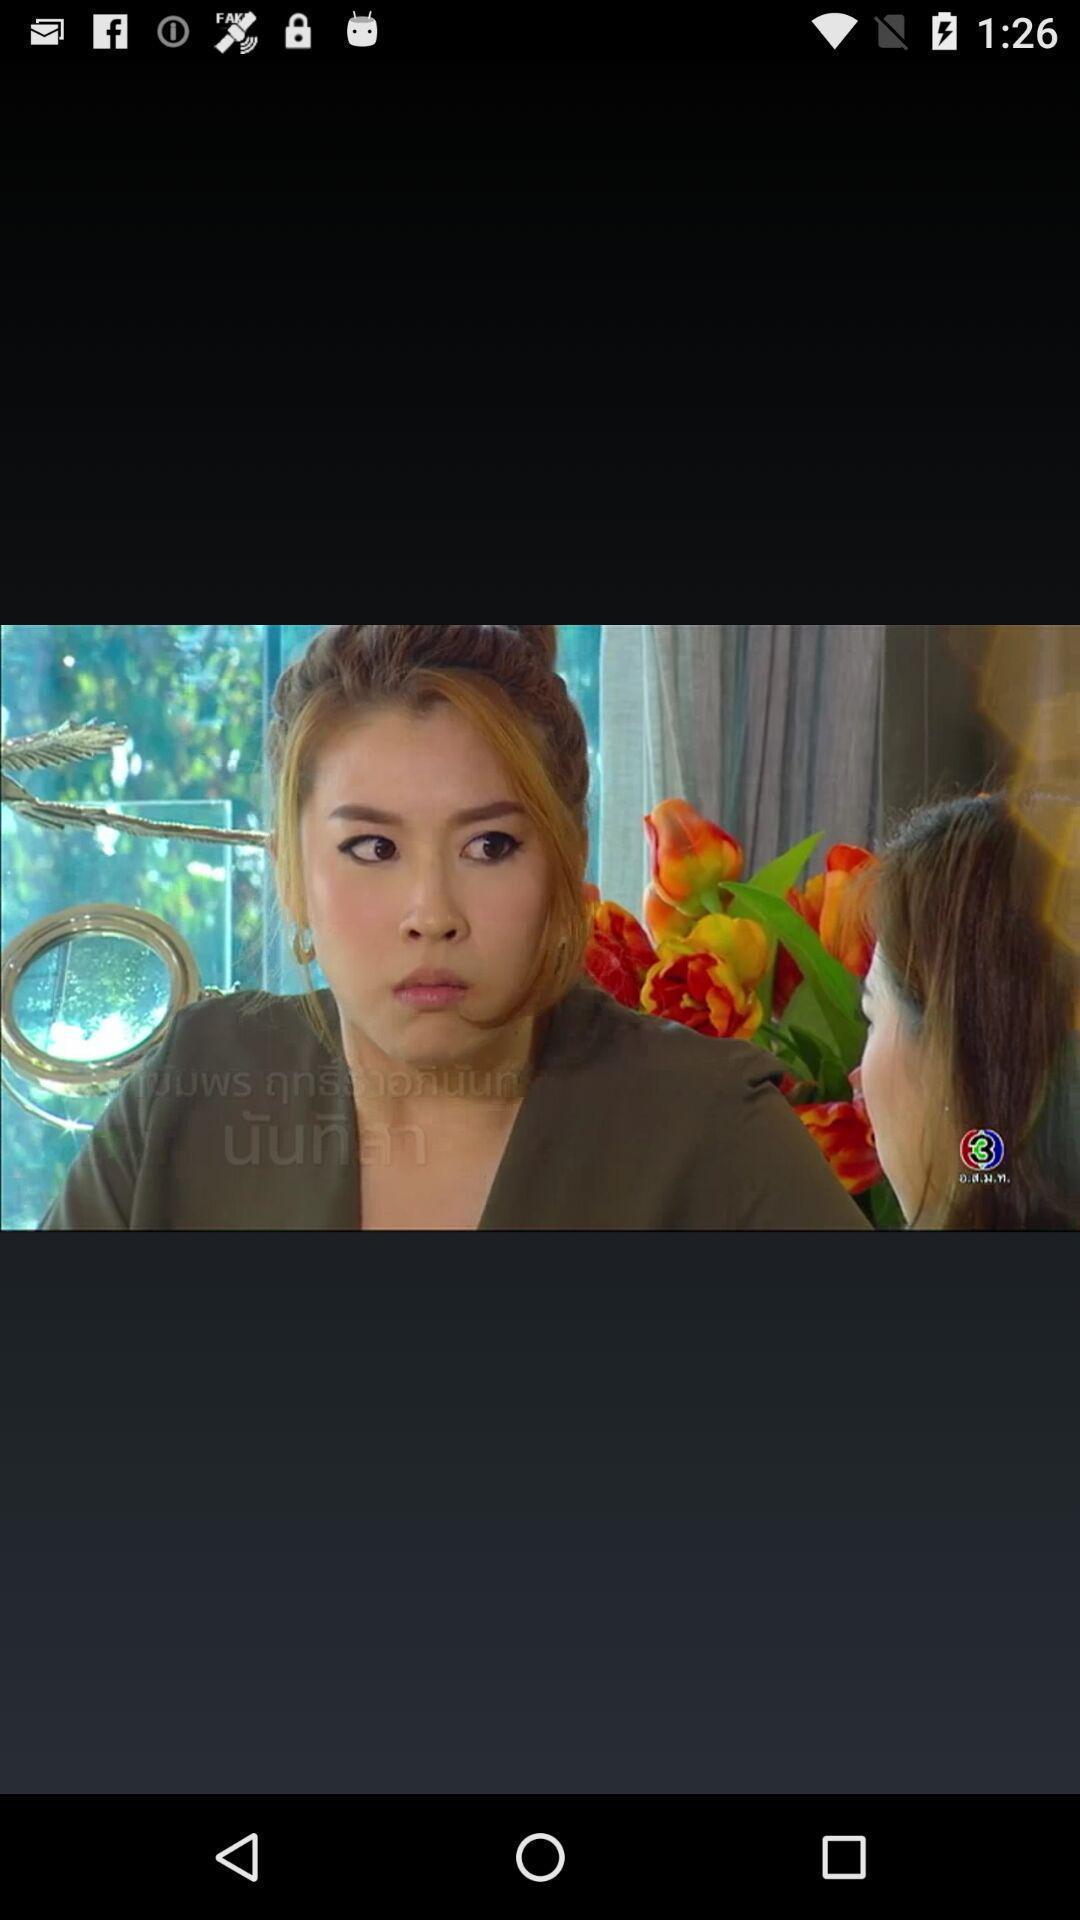What can you discern from this picture? Page shows the picture of a two woman. 